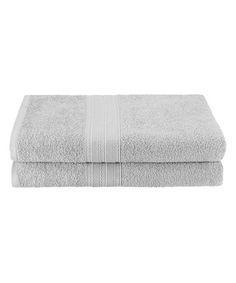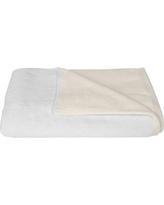The first image is the image on the left, the second image is the image on the right. Analyze the images presented: Is the assertion "An image shows a stack of at least two solid gray towels." valid? Answer yes or no. Yes. 